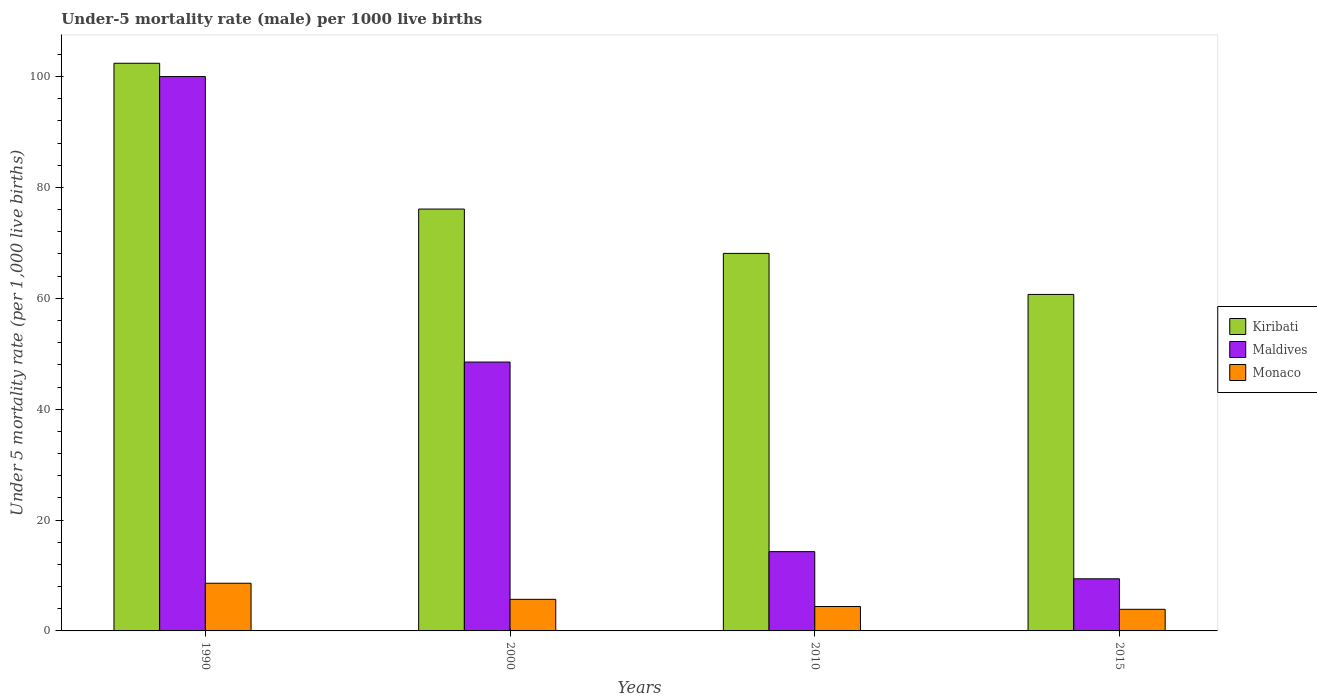How many groups of bars are there?
Give a very brief answer. 4. Are the number of bars per tick equal to the number of legend labels?
Your answer should be very brief. Yes. Are the number of bars on each tick of the X-axis equal?
Offer a terse response. Yes. How many bars are there on the 4th tick from the left?
Keep it short and to the point. 3. How many bars are there on the 2nd tick from the right?
Offer a very short reply. 3. What is the label of the 3rd group of bars from the left?
Offer a very short reply. 2010. What is the under-five mortality rate in Kiribati in 2000?
Offer a very short reply. 76.1. Across all years, what is the minimum under-five mortality rate in Kiribati?
Keep it short and to the point. 60.7. In which year was the under-five mortality rate in Monaco maximum?
Offer a terse response. 1990. In which year was the under-five mortality rate in Monaco minimum?
Your response must be concise. 2015. What is the total under-five mortality rate in Maldives in the graph?
Give a very brief answer. 172.2. What is the difference between the under-five mortality rate in Monaco in 2000 and that in 2015?
Your answer should be compact. 1.8. What is the difference between the under-five mortality rate in Maldives in 2000 and the under-five mortality rate in Kiribati in 2010?
Provide a short and direct response. -19.6. What is the average under-five mortality rate in Kiribati per year?
Your answer should be compact. 76.83. In the year 2000, what is the difference between the under-five mortality rate in Maldives and under-five mortality rate in Kiribati?
Your answer should be compact. -27.6. What is the ratio of the under-five mortality rate in Kiribati in 1990 to that in 2015?
Make the answer very short. 1.69. Is the under-five mortality rate in Maldives in 2000 less than that in 2015?
Your answer should be very brief. No. What is the difference between the highest and the second highest under-five mortality rate in Maldives?
Your response must be concise. 51.5. What is the difference between the highest and the lowest under-five mortality rate in Kiribati?
Give a very brief answer. 41.7. What does the 1st bar from the left in 2010 represents?
Your answer should be compact. Kiribati. What does the 2nd bar from the right in 2010 represents?
Provide a succinct answer. Maldives. How many bars are there?
Your answer should be very brief. 12. How many years are there in the graph?
Ensure brevity in your answer.  4. Are the values on the major ticks of Y-axis written in scientific E-notation?
Offer a terse response. No. Does the graph contain any zero values?
Your answer should be compact. No. Where does the legend appear in the graph?
Make the answer very short. Center right. How many legend labels are there?
Ensure brevity in your answer.  3. What is the title of the graph?
Make the answer very short. Under-5 mortality rate (male) per 1000 live births. What is the label or title of the X-axis?
Your answer should be compact. Years. What is the label or title of the Y-axis?
Provide a succinct answer. Under 5 mortality rate (per 1,0 live births). What is the Under 5 mortality rate (per 1,000 live births) in Kiribati in 1990?
Ensure brevity in your answer.  102.4. What is the Under 5 mortality rate (per 1,000 live births) in Kiribati in 2000?
Your answer should be very brief. 76.1. What is the Under 5 mortality rate (per 1,000 live births) of Maldives in 2000?
Give a very brief answer. 48.5. What is the Under 5 mortality rate (per 1,000 live births) in Monaco in 2000?
Provide a short and direct response. 5.7. What is the Under 5 mortality rate (per 1,000 live births) in Kiribati in 2010?
Offer a very short reply. 68.1. What is the Under 5 mortality rate (per 1,000 live births) of Maldives in 2010?
Offer a very short reply. 14.3. What is the Under 5 mortality rate (per 1,000 live births) of Monaco in 2010?
Offer a terse response. 4.4. What is the Under 5 mortality rate (per 1,000 live births) in Kiribati in 2015?
Your answer should be compact. 60.7. Across all years, what is the maximum Under 5 mortality rate (per 1,000 live births) in Kiribati?
Your response must be concise. 102.4. Across all years, what is the minimum Under 5 mortality rate (per 1,000 live births) of Kiribati?
Offer a very short reply. 60.7. Across all years, what is the minimum Under 5 mortality rate (per 1,000 live births) in Maldives?
Your response must be concise. 9.4. Across all years, what is the minimum Under 5 mortality rate (per 1,000 live births) in Monaco?
Give a very brief answer. 3.9. What is the total Under 5 mortality rate (per 1,000 live births) in Kiribati in the graph?
Provide a short and direct response. 307.3. What is the total Under 5 mortality rate (per 1,000 live births) of Maldives in the graph?
Your answer should be very brief. 172.2. What is the total Under 5 mortality rate (per 1,000 live births) in Monaco in the graph?
Your answer should be very brief. 22.6. What is the difference between the Under 5 mortality rate (per 1,000 live births) of Kiribati in 1990 and that in 2000?
Offer a terse response. 26.3. What is the difference between the Under 5 mortality rate (per 1,000 live births) in Maldives in 1990 and that in 2000?
Your response must be concise. 51.5. What is the difference between the Under 5 mortality rate (per 1,000 live births) of Monaco in 1990 and that in 2000?
Give a very brief answer. 2.9. What is the difference between the Under 5 mortality rate (per 1,000 live births) in Kiribati in 1990 and that in 2010?
Your answer should be compact. 34.3. What is the difference between the Under 5 mortality rate (per 1,000 live births) of Maldives in 1990 and that in 2010?
Your answer should be very brief. 85.7. What is the difference between the Under 5 mortality rate (per 1,000 live births) of Monaco in 1990 and that in 2010?
Offer a terse response. 4.2. What is the difference between the Under 5 mortality rate (per 1,000 live births) in Kiribati in 1990 and that in 2015?
Provide a short and direct response. 41.7. What is the difference between the Under 5 mortality rate (per 1,000 live births) in Maldives in 1990 and that in 2015?
Provide a short and direct response. 90.6. What is the difference between the Under 5 mortality rate (per 1,000 live births) of Monaco in 1990 and that in 2015?
Give a very brief answer. 4.7. What is the difference between the Under 5 mortality rate (per 1,000 live births) in Maldives in 2000 and that in 2010?
Offer a very short reply. 34.2. What is the difference between the Under 5 mortality rate (per 1,000 live births) in Monaco in 2000 and that in 2010?
Ensure brevity in your answer.  1.3. What is the difference between the Under 5 mortality rate (per 1,000 live births) in Maldives in 2000 and that in 2015?
Your response must be concise. 39.1. What is the difference between the Under 5 mortality rate (per 1,000 live births) of Kiribati in 1990 and the Under 5 mortality rate (per 1,000 live births) of Maldives in 2000?
Keep it short and to the point. 53.9. What is the difference between the Under 5 mortality rate (per 1,000 live births) in Kiribati in 1990 and the Under 5 mortality rate (per 1,000 live births) in Monaco in 2000?
Offer a terse response. 96.7. What is the difference between the Under 5 mortality rate (per 1,000 live births) of Maldives in 1990 and the Under 5 mortality rate (per 1,000 live births) of Monaco in 2000?
Keep it short and to the point. 94.3. What is the difference between the Under 5 mortality rate (per 1,000 live births) in Kiribati in 1990 and the Under 5 mortality rate (per 1,000 live births) in Maldives in 2010?
Your response must be concise. 88.1. What is the difference between the Under 5 mortality rate (per 1,000 live births) in Maldives in 1990 and the Under 5 mortality rate (per 1,000 live births) in Monaco in 2010?
Make the answer very short. 95.6. What is the difference between the Under 5 mortality rate (per 1,000 live births) in Kiribati in 1990 and the Under 5 mortality rate (per 1,000 live births) in Maldives in 2015?
Make the answer very short. 93. What is the difference between the Under 5 mortality rate (per 1,000 live births) of Kiribati in 1990 and the Under 5 mortality rate (per 1,000 live births) of Monaco in 2015?
Offer a terse response. 98.5. What is the difference between the Under 5 mortality rate (per 1,000 live births) of Maldives in 1990 and the Under 5 mortality rate (per 1,000 live births) of Monaco in 2015?
Ensure brevity in your answer.  96.1. What is the difference between the Under 5 mortality rate (per 1,000 live births) of Kiribati in 2000 and the Under 5 mortality rate (per 1,000 live births) of Maldives in 2010?
Offer a very short reply. 61.8. What is the difference between the Under 5 mortality rate (per 1,000 live births) in Kiribati in 2000 and the Under 5 mortality rate (per 1,000 live births) in Monaco in 2010?
Keep it short and to the point. 71.7. What is the difference between the Under 5 mortality rate (per 1,000 live births) of Maldives in 2000 and the Under 5 mortality rate (per 1,000 live births) of Monaco in 2010?
Your response must be concise. 44.1. What is the difference between the Under 5 mortality rate (per 1,000 live births) in Kiribati in 2000 and the Under 5 mortality rate (per 1,000 live births) in Maldives in 2015?
Your response must be concise. 66.7. What is the difference between the Under 5 mortality rate (per 1,000 live births) in Kiribati in 2000 and the Under 5 mortality rate (per 1,000 live births) in Monaco in 2015?
Offer a very short reply. 72.2. What is the difference between the Under 5 mortality rate (per 1,000 live births) of Maldives in 2000 and the Under 5 mortality rate (per 1,000 live births) of Monaco in 2015?
Offer a very short reply. 44.6. What is the difference between the Under 5 mortality rate (per 1,000 live births) in Kiribati in 2010 and the Under 5 mortality rate (per 1,000 live births) in Maldives in 2015?
Ensure brevity in your answer.  58.7. What is the difference between the Under 5 mortality rate (per 1,000 live births) in Kiribati in 2010 and the Under 5 mortality rate (per 1,000 live births) in Monaco in 2015?
Your response must be concise. 64.2. What is the difference between the Under 5 mortality rate (per 1,000 live births) of Maldives in 2010 and the Under 5 mortality rate (per 1,000 live births) of Monaco in 2015?
Offer a very short reply. 10.4. What is the average Under 5 mortality rate (per 1,000 live births) of Kiribati per year?
Your response must be concise. 76.83. What is the average Under 5 mortality rate (per 1,000 live births) in Maldives per year?
Your answer should be compact. 43.05. What is the average Under 5 mortality rate (per 1,000 live births) of Monaco per year?
Your answer should be compact. 5.65. In the year 1990, what is the difference between the Under 5 mortality rate (per 1,000 live births) of Kiribati and Under 5 mortality rate (per 1,000 live births) of Monaco?
Offer a terse response. 93.8. In the year 1990, what is the difference between the Under 5 mortality rate (per 1,000 live births) of Maldives and Under 5 mortality rate (per 1,000 live births) of Monaco?
Make the answer very short. 91.4. In the year 2000, what is the difference between the Under 5 mortality rate (per 1,000 live births) of Kiribati and Under 5 mortality rate (per 1,000 live births) of Maldives?
Your response must be concise. 27.6. In the year 2000, what is the difference between the Under 5 mortality rate (per 1,000 live births) of Kiribati and Under 5 mortality rate (per 1,000 live births) of Monaco?
Ensure brevity in your answer.  70.4. In the year 2000, what is the difference between the Under 5 mortality rate (per 1,000 live births) of Maldives and Under 5 mortality rate (per 1,000 live births) of Monaco?
Your answer should be very brief. 42.8. In the year 2010, what is the difference between the Under 5 mortality rate (per 1,000 live births) in Kiribati and Under 5 mortality rate (per 1,000 live births) in Maldives?
Ensure brevity in your answer.  53.8. In the year 2010, what is the difference between the Under 5 mortality rate (per 1,000 live births) in Kiribati and Under 5 mortality rate (per 1,000 live births) in Monaco?
Ensure brevity in your answer.  63.7. In the year 2015, what is the difference between the Under 5 mortality rate (per 1,000 live births) in Kiribati and Under 5 mortality rate (per 1,000 live births) in Maldives?
Your answer should be very brief. 51.3. In the year 2015, what is the difference between the Under 5 mortality rate (per 1,000 live births) in Kiribati and Under 5 mortality rate (per 1,000 live births) in Monaco?
Provide a succinct answer. 56.8. What is the ratio of the Under 5 mortality rate (per 1,000 live births) of Kiribati in 1990 to that in 2000?
Your answer should be compact. 1.35. What is the ratio of the Under 5 mortality rate (per 1,000 live births) of Maldives in 1990 to that in 2000?
Provide a short and direct response. 2.06. What is the ratio of the Under 5 mortality rate (per 1,000 live births) of Monaco in 1990 to that in 2000?
Keep it short and to the point. 1.51. What is the ratio of the Under 5 mortality rate (per 1,000 live births) in Kiribati in 1990 to that in 2010?
Your answer should be compact. 1.5. What is the ratio of the Under 5 mortality rate (per 1,000 live births) of Maldives in 1990 to that in 2010?
Offer a terse response. 6.99. What is the ratio of the Under 5 mortality rate (per 1,000 live births) in Monaco in 1990 to that in 2010?
Make the answer very short. 1.95. What is the ratio of the Under 5 mortality rate (per 1,000 live births) of Kiribati in 1990 to that in 2015?
Provide a short and direct response. 1.69. What is the ratio of the Under 5 mortality rate (per 1,000 live births) in Maldives in 1990 to that in 2015?
Keep it short and to the point. 10.64. What is the ratio of the Under 5 mortality rate (per 1,000 live births) in Monaco in 1990 to that in 2015?
Offer a very short reply. 2.21. What is the ratio of the Under 5 mortality rate (per 1,000 live births) in Kiribati in 2000 to that in 2010?
Your answer should be compact. 1.12. What is the ratio of the Under 5 mortality rate (per 1,000 live births) in Maldives in 2000 to that in 2010?
Ensure brevity in your answer.  3.39. What is the ratio of the Under 5 mortality rate (per 1,000 live births) in Monaco in 2000 to that in 2010?
Ensure brevity in your answer.  1.3. What is the ratio of the Under 5 mortality rate (per 1,000 live births) in Kiribati in 2000 to that in 2015?
Your answer should be compact. 1.25. What is the ratio of the Under 5 mortality rate (per 1,000 live births) of Maldives in 2000 to that in 2015?
Provide a short and direct response. 5.16. What is the ratio of the Under 5 mortality rate (per 1,000 live births) in Monaco in 2000 to that in 2015?
Offer a terse response. 1.46. What is the ratio of the Under 5 mortality rate (per 1,000 live births) in Kiribati in 2010 to that in 2015?
Your response must be concise. 1.12. What is the ratio of the Under 5 mortality rate (per 1,000 live births) in Maldives in 2010 to that in 2015?
Give a very brief answer. 1.52. What is the ratio of the Under 5 mortality rate (per 1,000 live births) in Monaco in 2010 to that in 2015?
Provide a succinct answer. 1.13. What is the difference between the highest and the second highest Under 5 mortality rate (per 1,000 live births) in Kiribati?
Give a very brief answer. 26.3. What is the difference between the highest and the second highest Under 5 mortality rate (per 1,000 live births) of Maldives?
Your response must be concise. 51.5. What is the difference between the highest and the second highest Under 5 mortality rate (per 1,000 live births) in Monaco?
Your answer should be very brief. 2.9. What is the difference between the highest and the lowest Under 5 mortality rate (per 1,000 live births) in Kiribati?
Your response must be concise. 41.7. What is the difference between the highest and the lowest Under 5 mortality rate (per 1,000 live births) in Maldives?
Provide a short and direct response. 90.6. What is the difference between the highest and the lowest Under 5 mortality rate (per 1,000 live births) of Monaco?
Give a very brief answer. 4.7. 